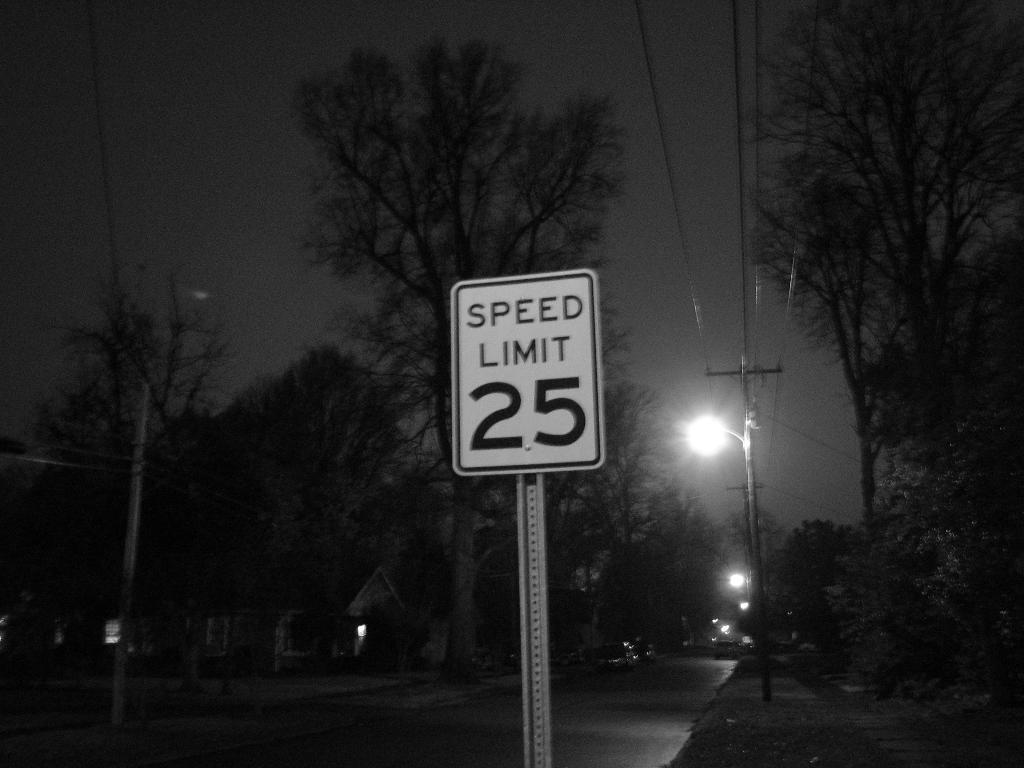Describe this image in one or two sentences. In this image in front there is a board. In the center of the image there are vehicles on the road. There are current polls. In the background of the image there are trees, buildings, moon and sky. 